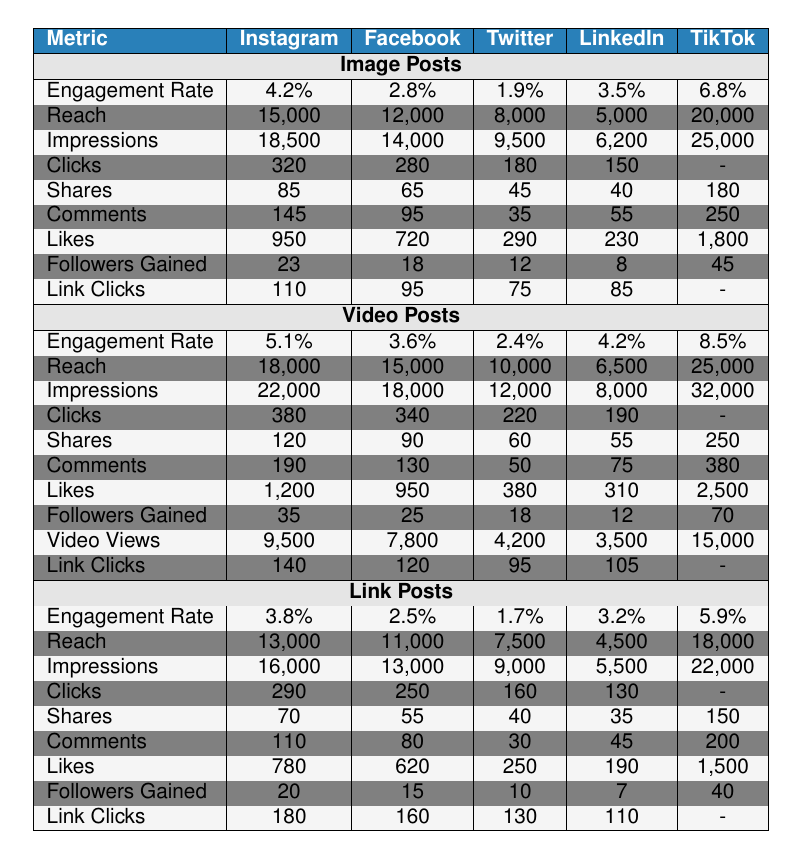What is the engagement rate for TikTok video posts? Referring to the "Video Posts" section for TikTok, the engagement rate is listed as 8.5%.
Answer: 8.5% Which social media channel has the highest number of likes for image posts? Looking at the "Image Posts" section, TikTok has the highest number of likes at 1,800.
Answer: TikTok What is the total number of shares for Facebook across all post types? From the Image, Video, and Link posts for Facebook, the shares are 65 (Image) + 90 (Video) + 55 (Link) = 210.
Answer: 210 Which channel had the highest reach for link posts? In the "Link Posts" section, TikTok had the highest reach of 18,000.
Answer: TikTok Are there any channels where clicks for video posts are not reported? In the "Video Posts" section, both Instagram and TikTok have missing values for clicks, indicating no data available.
Answer: Yes What is the average engagement rate for all post types on Instagram? The engagement rates for Instagram in the table are 4.2% (Image) + 5.1% (Video) + 3.8% (Link). The average is (4.2 + 5.1 + 3.8) / 3 = 4.37%.
Answer: 4.37% Which post type received the most video views on TikTok? In the "Video Posts" section, TikTok's video views are listed as 15,000, which is the only value provided for video views compared to other channels offering lower numbers.
Answer: Video Posts What percentage of followers gained on Instagram from video posts compared to the total followers gained from all post types? For Instagram, the followers gained are 23 (Image) + 35 (Video) + 20 (Link) = 78. The percentage from video posts is (35 / 78) * 100 ≈ 44.87%.
Answer: 44.87% Which channels have a higher reach for image posts than for video posts? Comparing the reach for both post types, Instagram (15,000 for image vs 18,000 for video) and Facebook (12,000 for image vs 15,000 for video) both have lower or equal reach for video posts. Twitter (8,000 vs 10,000), LinkedIn (5,000 vs 6,500), and TikTok (20,000 vs 25,000) all show higher reaches for video posts. Thus, none have higher reach for image posts.
Answer: No Is the engagement rate for Facebook link posts lower than that for Twitter? The engagement rate for Facebook link posts is 2.5%, and for Twitter, it is 1.7%, making Facebook’s engagement rate higher.
Answer: No 